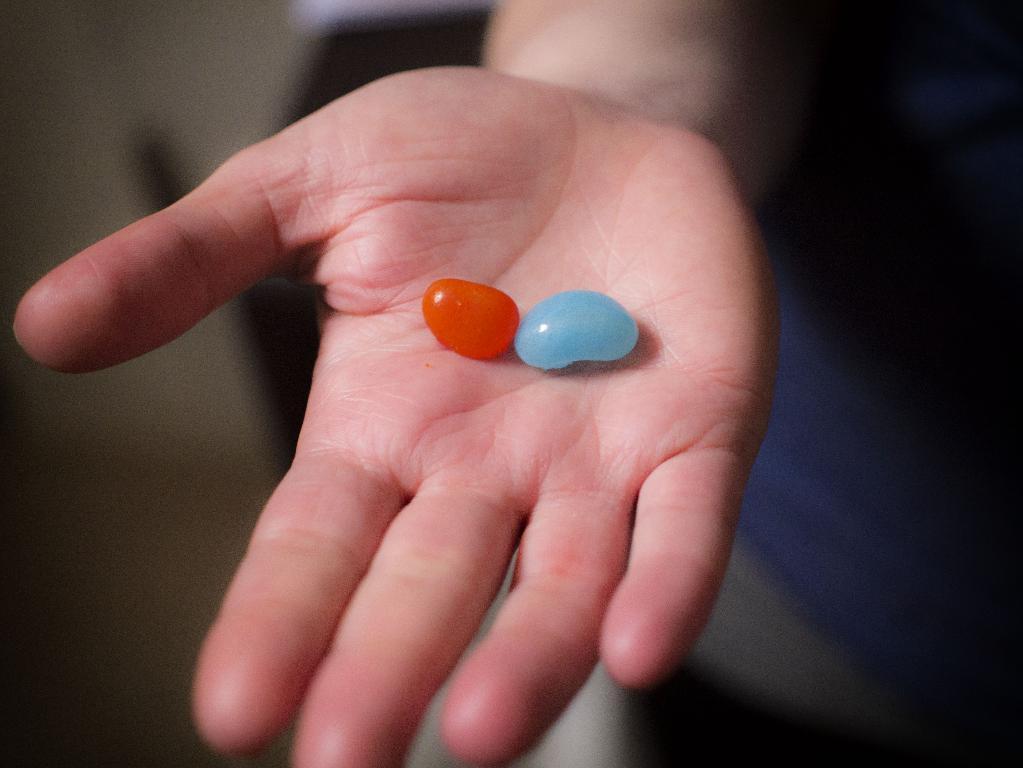Please provide a concise description of this image. This is a zoomed in picture. In the center we can see the hand of a person holding some objects. The background of the image is blurry and we can see some items in the background. 